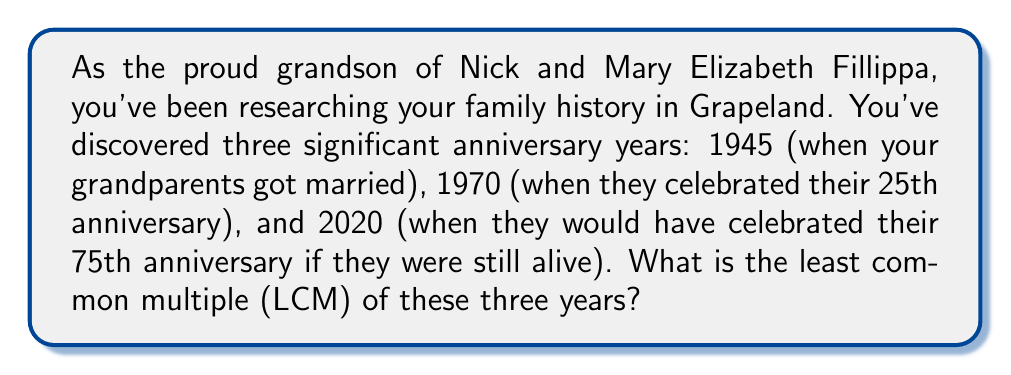Can you solve this math problem? To find the least common multiple (LCM) of 1945, 1970, and 2020, we'll follow these steps:

1) First, let's factor each number:

   1945 = 5 × 389
   1970 = 2 × 5 × 197
   2020 = 2² × 5 × 101

2) The LCM will include the highest power of each prime factor that appears in any of the numbers. So we need:

   - 2² (from 2020)
   - 5 (appears in all three)
   - 389 (from 1945)
   - 197 (from 1970)
   - 101 (from 2020)

3) Now, we multiply these factors:

   $$ LCM = 2^2 \times 5 \times 389 \times 197 \times 101 $$

4) Let's calculate this:

   $$ LCM = 4 \times 5 \times 389 \times 197 \times 101 $$
   $$ = 20 \times 389 \times 197 \times 101 $$
   $$ = 7,780 \times 197 \times 101 $$
   $$ = 1,532,660 \times 101 $$
   $$ = 154,798,660 $$

Therefore, the least common multiple of 1945, 1970, and 2020 is 154,798,660.
Answer: 154,798,660 